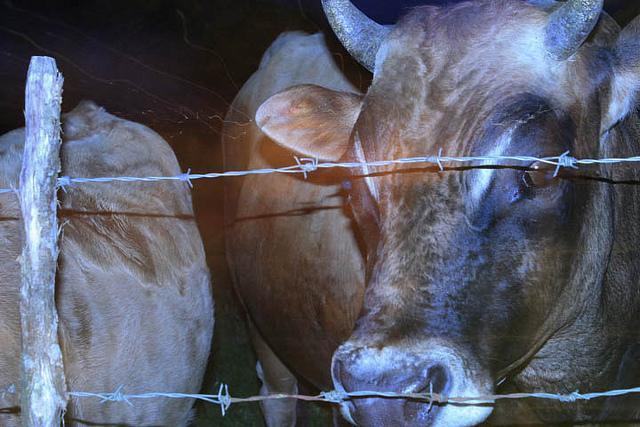How many cows are there?
Give a very brief answer. 2. 